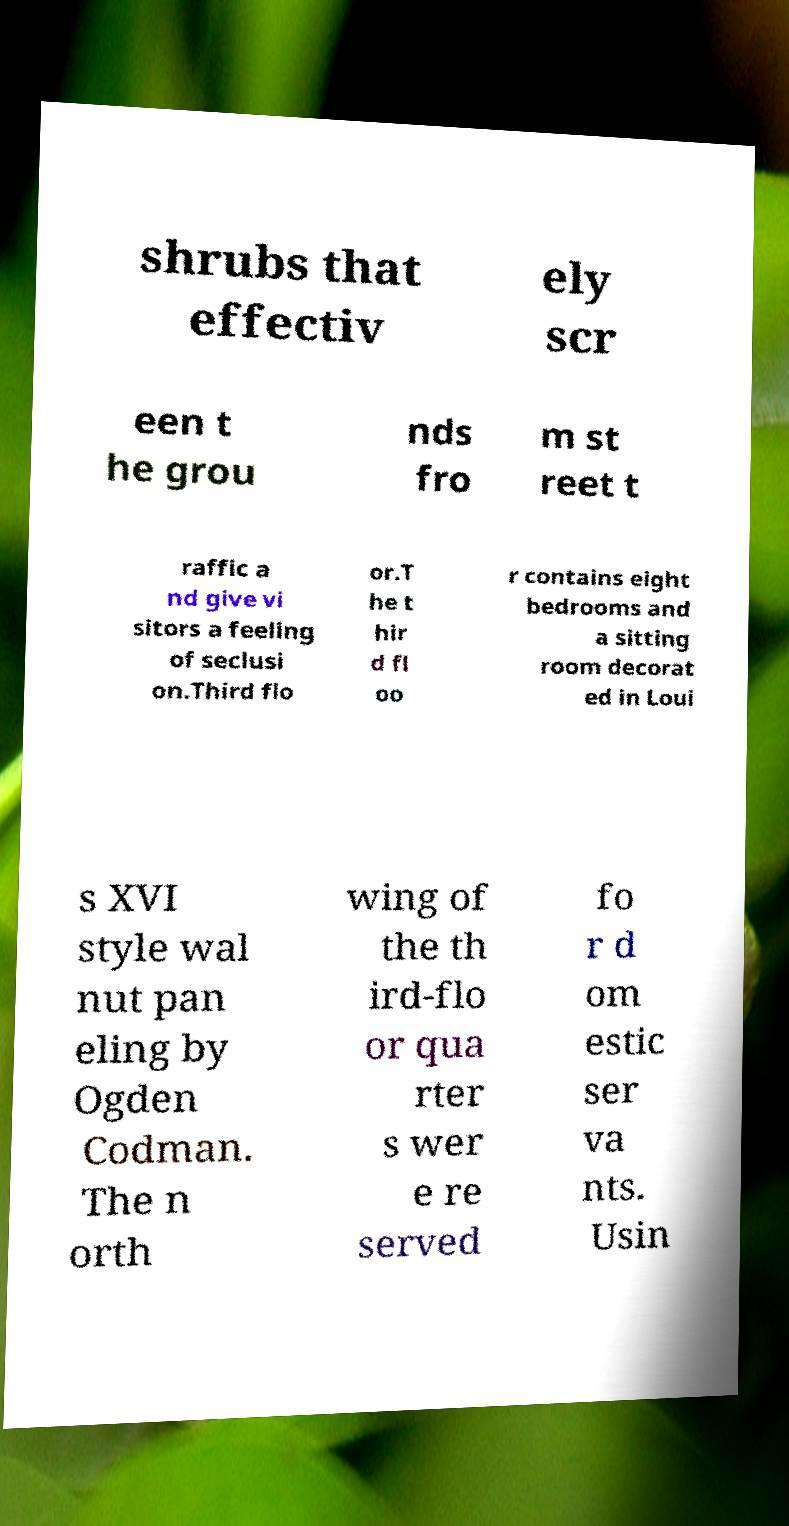Can you accurately transcribe the text from the provided image for me? shrubs that effectiv ely scr een t he grou nds fro m st reet t raffic a nd give vi sitors a feeling of seclusi on.Third flo or.T he t hir d fl oo r contains eight bedrooms and a sitting room decorat ed in Loui s XVI style wal nut pan eling by Ogden Codman. The n orth wing of the th ird-flo or qua rter s wer e re served fo r d om estic ser va nts. Usin 